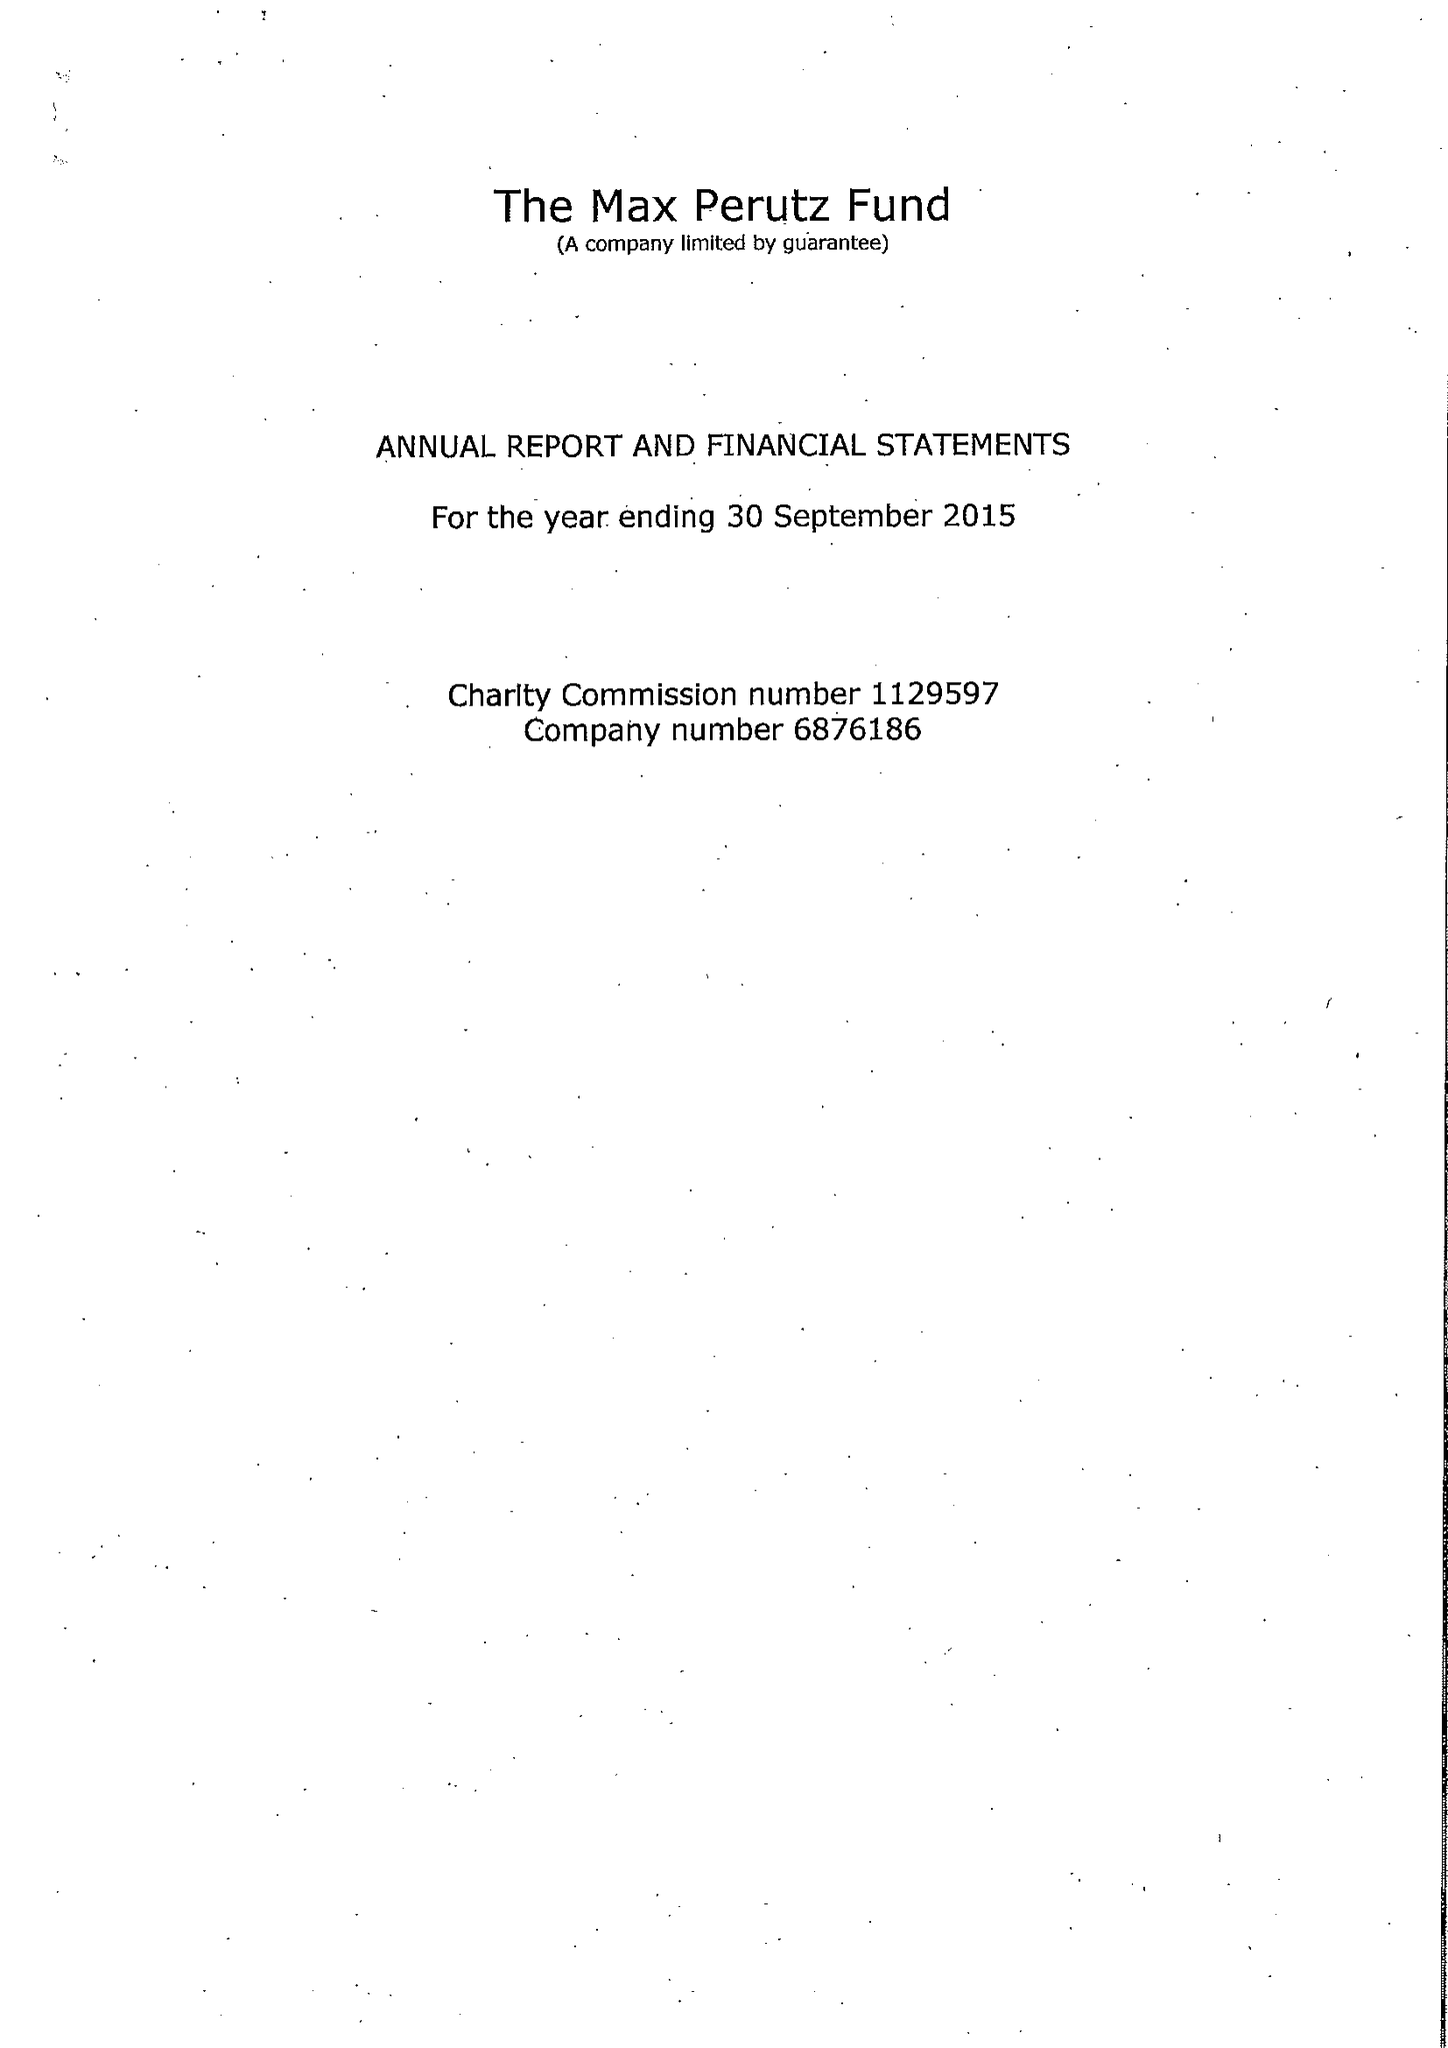What is the value for the charity_name?
Answer the question using a single word or phrase. The Max Perutz Fund 